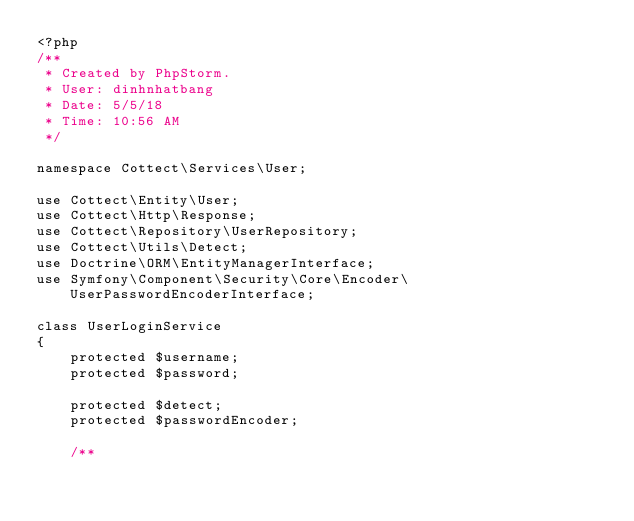Convert code to text. <code><loc_0><loc_0><loc_500><loc_500><_PHP_><?php
/**
 * Created by PhpStorm.
 * User: dinhnhatbang
 * Date: 5/5/18
 * Time: 10:56 AM
 */

namespace Cottect\Services\User;

use Cottect\Entity\User;
use Cottect\Http\Response;
use Cottect\Repository\UserRepository;
use Cottect\Utils\Detect;
use Doctrine\ORM\EntityManagerInterface;
use Symfony\Component\Security\Core\Encoder\UserPasswordEncoderInterface;

class UserLoginService
{
    protected $username;
    protected $password;

    protected $detect;
    protected $passwordEncoder;

    /**</code> 